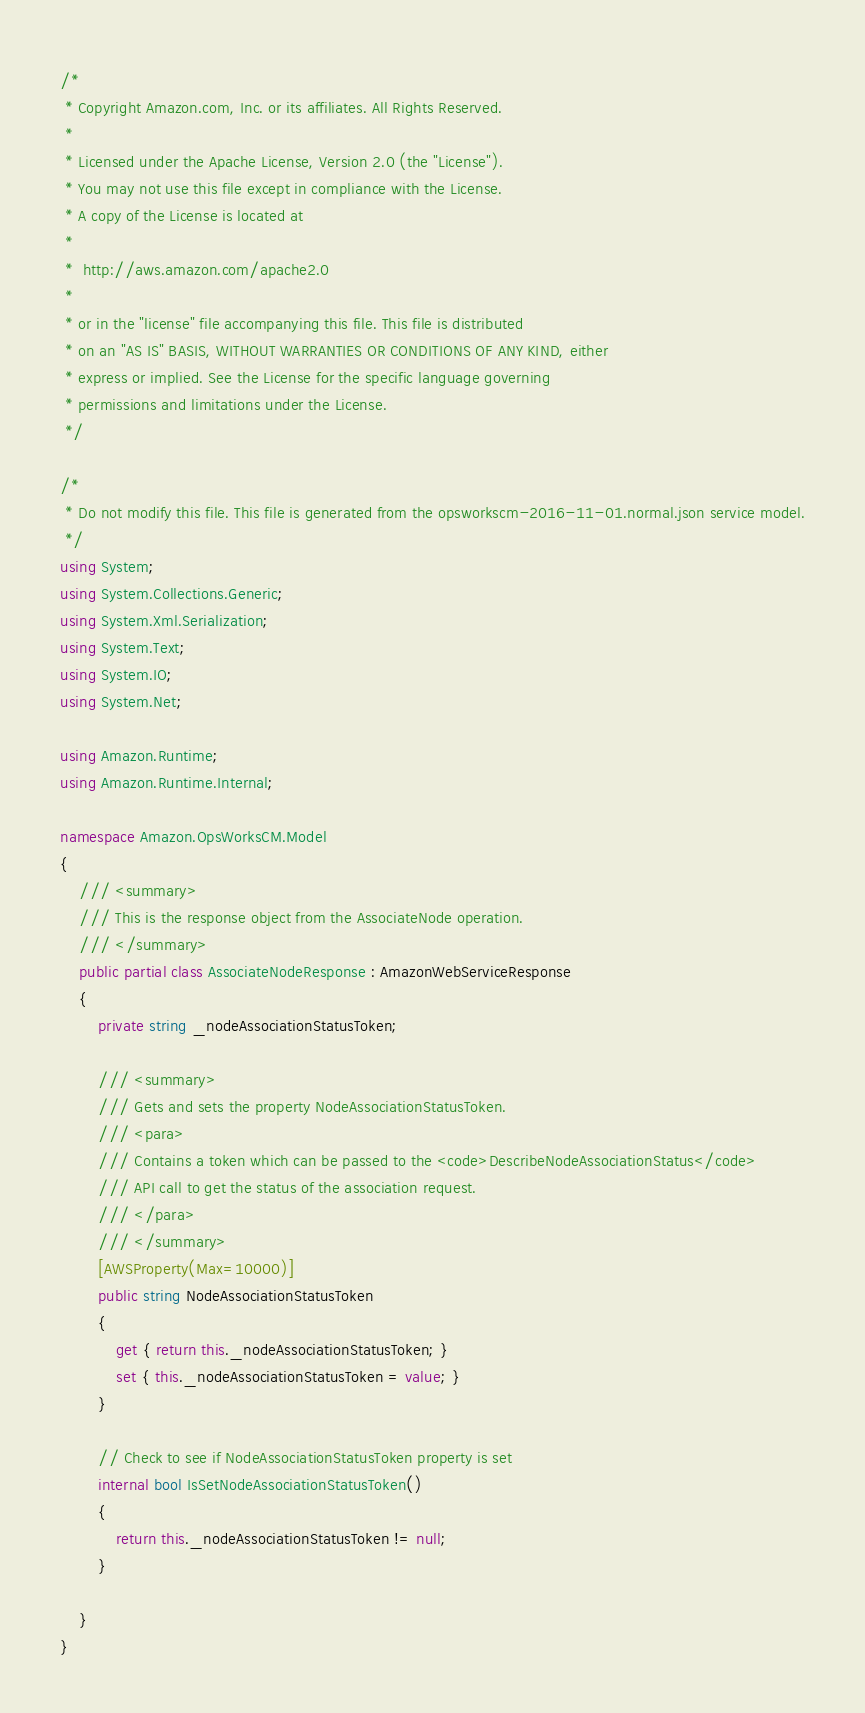Convert code to text. <code><loc_0><loc_0><loc_500><loc_500><_C#_>/*
 * Copyright Amazon.com, Inc. or its affiliates. All Rights Reserved.
 * 
 * Licensed under the Apache License, Version 2.0 (the "License").
 * You may not use this file except in compliance with the License.
 * A copy of the License is located at
 * 
 *  http://aws.amazon.com/apache2.0
 * 
 * or in the "license" file accompanying this file. This file is distributed
 * on an "AS IS" BASIS, WITHOUT WARRANTIES OR CONDITIONS OF ANY KIND, either
 * express or implied. See the License for the specific language governing
 * permissions and limitations under the License.
 */

/*
 * Do not modify this file. This file is generated from the opsworkscm-2016-11-01.normal.json service model.
 */
using System;
using System.Collections.Generic;
using System.Xml.Serialization;
using System.Text;
using System.IO;
using System.Net;

using Amazon.Runtime;
using Amazon.Runtime.Internal;

namespace Amazon.OpsWorksCM.Model
{
    /// <summary>
    /// This is the response object from the AssociateNode operation.
    /// </summary>
    public partial class AssociateNodeResponse : AmazonWebServiceResponse
    {
        private string _nodeAssociationStatusToken;

        /// <summary>
        /// Gets and sets the property NodeAssociationStatusToken. 
        /// <para>
        /// Contains a token which can be passed to the <code>DescribeNodeAssociationStatus</code>
        /// API call to get the status of the association request. 
        /// </para>
        /// </summary>
        [AWSProperty(Max=10000)]
        public string NodeAssociationStatusToken
        {
            get { return this._nodeAssociationStatusToken; }
            set { this._nodeAssociationStatusToken = value; }
        }

        // Check to see if NodeAssociationStatusToken property is set
        internal bool IsSetNodeAssociationStatusToken()
        {
            return this._nodeAssociationStatusToken != null;
        }

    }
}</code> 